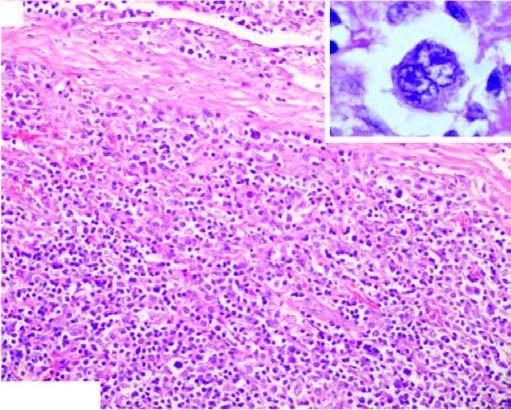what is there of mature lymphocytes, plasma cells, neutrophils and eosinophils and classic rs cells in the centre of the field inbox in right figure?
Answer the question using a single word or phrase. Admixture 